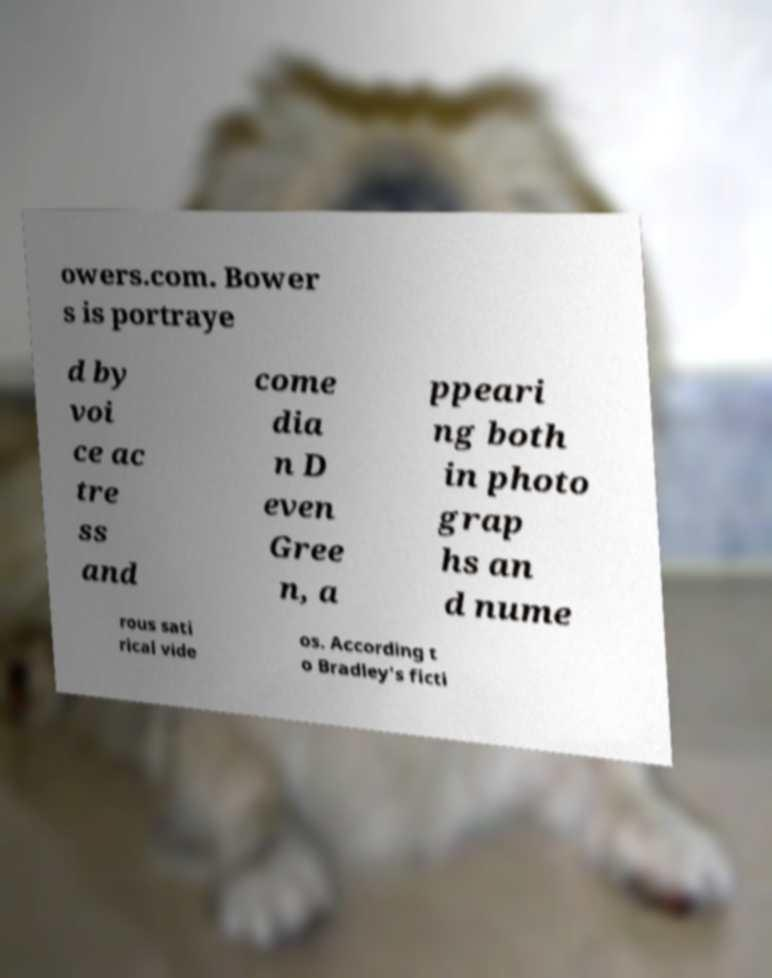What messages or text are displayed in this image? I need them in a readable, typed format. owers.com. Bower s is portraye d by voi ce ac tre ss and come dia n D even Gree n, a ppeari ng both in photo grap hs an d nume rous sati rical vide os. According t o Bradley's ficti 